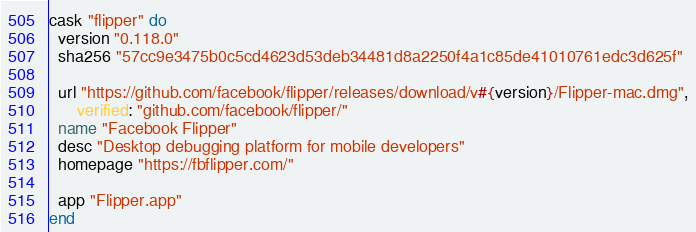Convert code to text. <code><loc_0><loc_0><loc_500><loc_500><_Ruby_>cask "flipper" do
  version "0.118.0"
  sha256 "57cc9e3475b0c5cd4623d53deb34481d8a2250f4a1c85de41010761edc3d625f"

  url "https://github.com/facebook/flipper/releases/download/v#{version}/Flipper-mac.dmg",
      verified: "github.com/facebook/flipper/"
  name "Facebook Flipper"
  desc "Desktop debugging platform for mobile developers"
  homepage "https://fbflipper.com/"

  app "Flipper.app"
end
</code> 